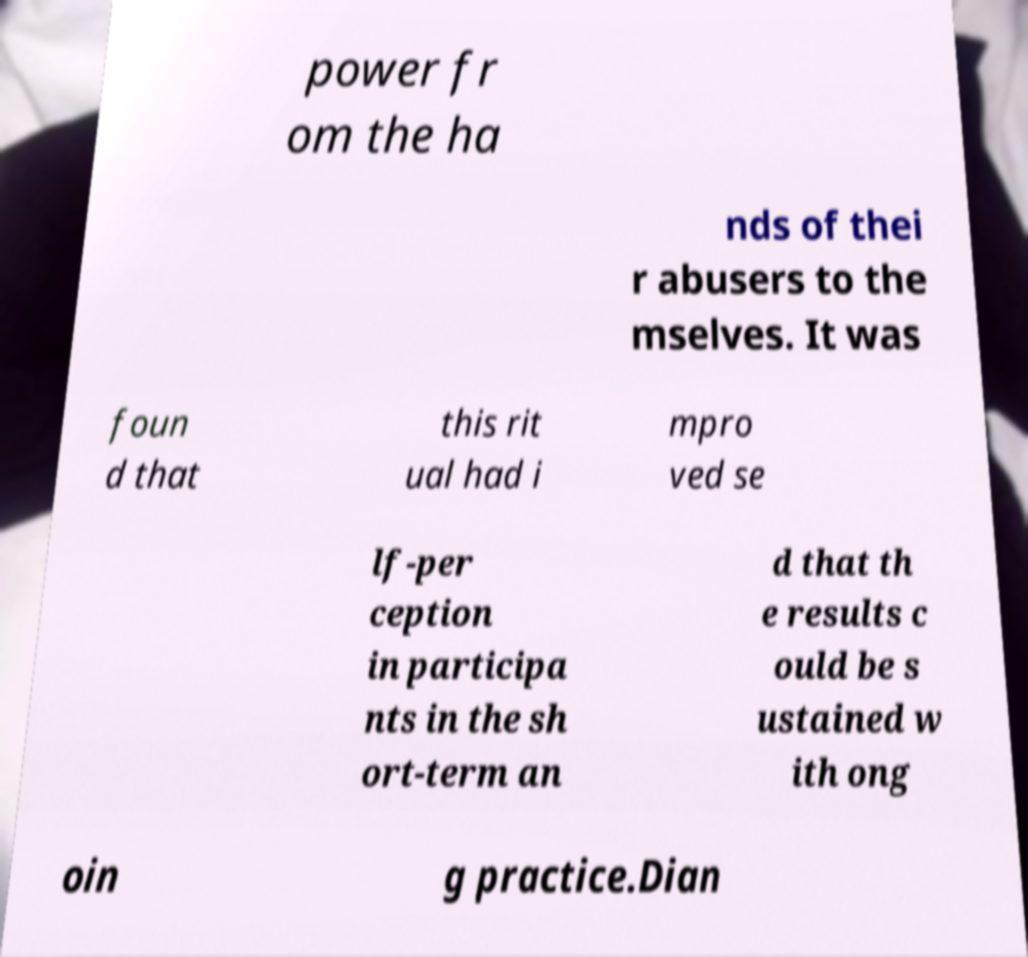For documentation purposes, I need the text within this image transcribed. Could you provide that? power fr om the ha nds of thei r abusers to the mselves. It was foun d that this rit ual had i mpro ved se lf-per ception in participa nts in the sh ort-term an d that th e results c ould be s ustained w ith ong oin g practice.Dian 